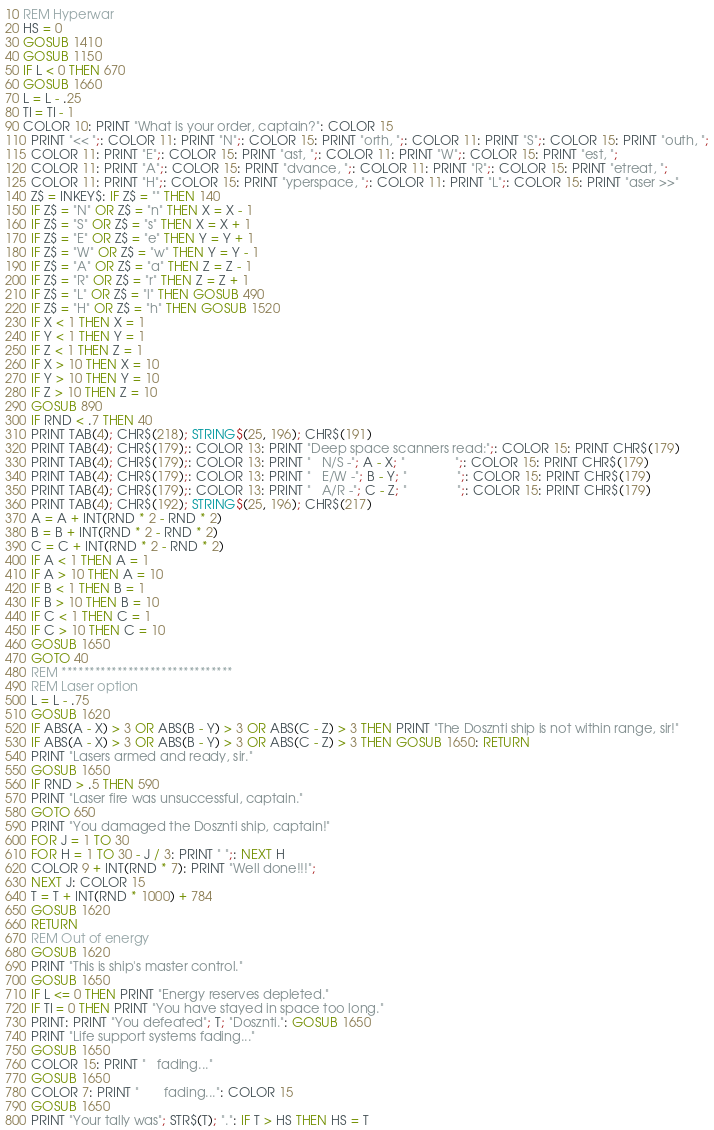Convert code to text. <code><loc_0><loc_0><loc_500><loc_500><_VisualBasic_>10 REM Hyperwar
20 HS = 0
30 GOSUB 1410
40 GOSUB 1150
50 IF L < 0 THEN 670
60 GOSUB 1660
70 L = L - .25
80 TI = TI - 1
90 COLOR 10: PRINT "What is your order, captain?": COLOR 15
110 PRINT "<< ";: COLOR 11: PRINT "N";: COLOR 15: PRINT "orth, ";: COLOR 11: PRINT "S";: COLOR 15: PRINT "outh, ";
115 COLOR 11: PRINT "E";: COLOR 15: PRINT "ast, ";: COLOR 11: PRINT "W";: COLOR 15: PRINT "est, ";
120 COLOR 11: PRINT "A";: COLOR 15: PRINT "dvance, ";: COLOR 11: PRINT "R";: COLOR 15: PRINT "etreat, ";
125 COLOR 11: PRINT "H";: COLOR 15: PRINT "yperspace, ";: COLOR 11: PRINT "L";: COLOR 15: PRINT "aser >>"
140 Z$ = INKEY$: IF Z$ = "" THEN 140
150 IF Z$ = "N" OR Z$ = "n" THEN X = X - 1
160 IF Z$ = "S" OR Z$ = "s" THEN X = X + 1
170 IF Z$ = "E" OR Z$ = "e" THEN Y = Y + 1
180 IF Z$ = "W" OR Z$ = "w" THEN Y = Y - 1
190 IF Z$ = "A" OR Z$ = "a" THEN Z = Z - 1
200 IF Z$ = "R" OR Z$ = "r" THEN Z = Z + 1
210 IF Z$ = "L" OR Z$ = "l" THEN GOSUB 490
220 IF Z$ = "H" OR Z$ = "h" THEN GOSUB 1520
230 IF X < 1 THEN X = 1
240 IF Y < 1 THEN Y = 1
250 IF Z < 1 THEN Z = 1
260 IF X > 10 THEN X = 10
270 IF Y > 10 THEN Y = 10
280 IF Z > 10 THEN Z = 10
290 GOSUB 890
300 IF RND < .7 THEN 40
310 PRINT TAB(4); CHR$(218); STRING$(25, 196); CHR$(191)
320 PRINT TAB(4); CHR$(179);: COLOR 13: PRINT "Deep space scanners read:";: COLOR 15: PRINT CHR$(179)
330 PRINT TAB(4); CHR$(179);: COLOR 13: PRINT "   N/S -"; A - X; "              ";: COLOR 15: PRINT CHR$(179)
340 PRINT TAB(4); CHR$(179);: COLOR 13: PRINT "   E/W -"; B - Y; "              ";: COLOR 15: PRINT CHR$(179)
350 PRINT TAB(4); CHR$(179);: COLOR 13: PRINT "   A/R -"; C - Z; "              ";: COLOR 15: PRINT CHR$(179)
360 PRINT TAB(4); CHR$(192); STRING$(25, 196); CHR$(217)
370 A = A + INT(RND * 2 - RND * 2)
380 B = B + INT(RND * 2 - RND * 2)
390 C = C + INT(RND * 2 - RND * 2)
400 IF A < 1 THEN A = 1
410 IF A > 10 THEN A = 10
420 IF B < 1 THEN B = 1
430 IF B > 10 THEN B = 10
440 IF C < 1 THEN C = 1
450 IF C > 10 THEN C = 10
460 GOSUB 1650
470 GOTO 40
480 REM *******************************
490 REM Laser option
500 L = L - .75
510 GOSUB 1620
520 IF ABS(A - X) > 3 OR ABS(B - Y) > 3 OR ABS(C - Z) > 3 THEN PRINT "The Dosznti ship is not within range, sir!"
530 IF ABS(A - X) > 3 OR ABS(B - Y) > 3 OR ABS(C - Z) > 3 THEN GOSUB 1650: RETURN
540 PRINT "Lasers armed and ready, sir."
550 GOSUB 1650
560 IF RND > .5 THEN 590
570 PRINT "Laser fire was unsuccessful, captain."
580 GOTO 650
590 PRINT "You damaged the Dosznti ship, captain!"
600 FOR J = 1 TO 30
610 FOR H = 1 TO 30 - J / 3: PRINT " ";: NEXT H
620 COLOR 9 + INT(RND * 7): PRINT "Well done!!!";
630 NEXT J: COLOR 15
640 T = T + INT(RND * 1000) + 784
650 GOSUB 1620
660 RETURN
670 REM Out of energy
680 GOSUB 1620
690 PRINT "This is ship's master control."
700 GOSUB 1650
710 IF L <= 0 THEN PRINT "Energy reserves depleted."
720 IF TI = 0 THEN PRINT "You have stayed in space too long."
730 PRINT: PRINT "You defeated"; T; "Dosznti.": GOSUB 1650
740 PRINT "Life support systems fading..."
750 GOSUB 1650
760 COLOR 15: PRINT "   fading..."
770 GOSUB 1650
780 COLOR 7: PRINT "       fading...": COLOR 15
790 GOSUB 1650
800 PRINT "Your tally was"; STR$(T); ".": IF T > HS THEN HS = T</code> 